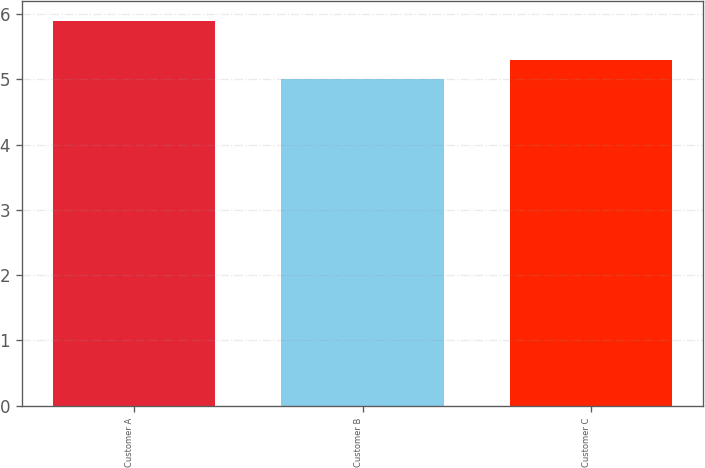<chart> <loc_0><loc_0><loc_500><loc_500><bar_chart><fcel>Customer A<fcel>Customer B<fcel>Customer C<nl><fcel>5.9<fcel>5<fcel>5.3<nl></chart> 